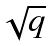<formula> <loc_0><loc_0><loc_500><loc_500>\sqrt { q }</formula> 